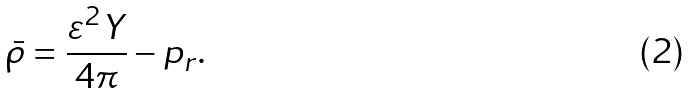<formula> <loc_0><loc_0><loc_500><loc_500>\bar { \rho } = \frac { \varepsilon ^ { 2 } Y } { 4 \pi } - p _ { r } \text {.}</formula> 